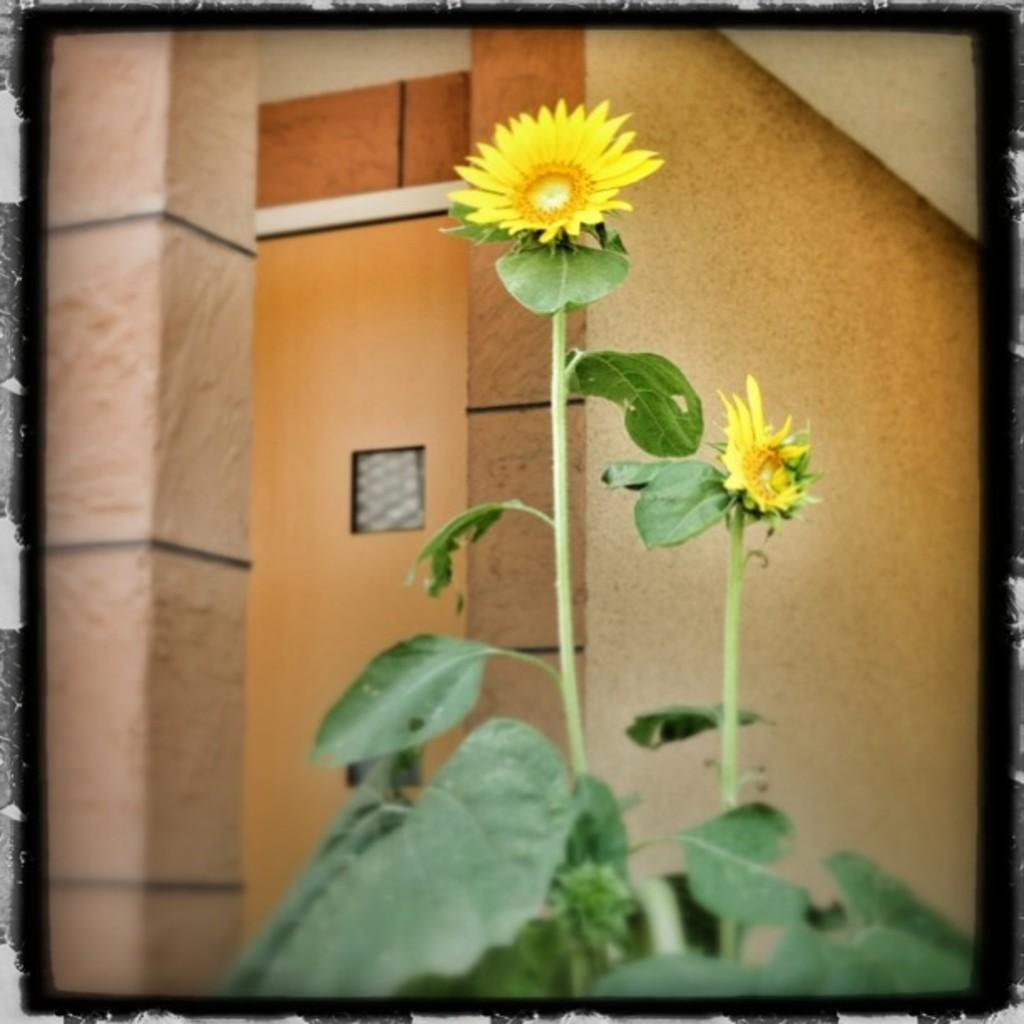What type of living organism can be seen in the image? There is a plant in the image. How many flowers are visible in the image? There are two flowers in the front of the image. What can be seen in the background of the image? There is a wall in the background of the image. What type of rhythm does the governor use to control the heat in the image? There is no governor or heat present in the image; it features a plant with two flowers and a wall in the background. 